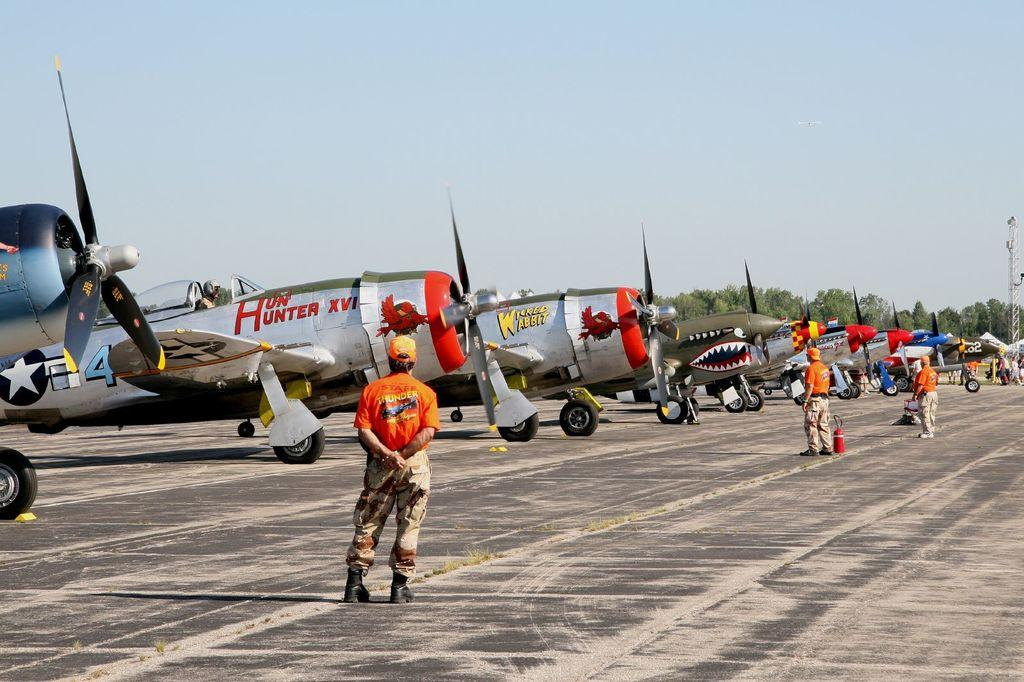<image>
Share a concise interpretation of the image provided. An airplane named Hun' Hunter XVI sits on a runway next to several other planes. 